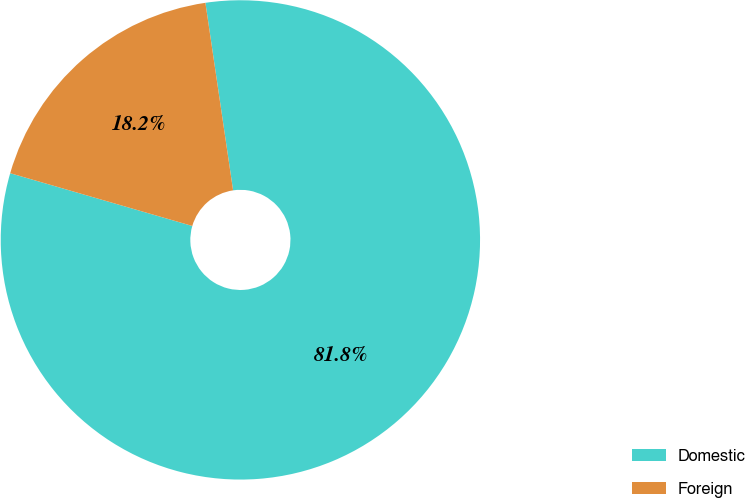Convert chart to OTSL. <chart><loc_0><loc_0><loc_500><loc_500><pie_chart><fcel>Domestic<fcel>Foreign<nl><fcel>81.82%<fcel>18.18%<nl></chart> 